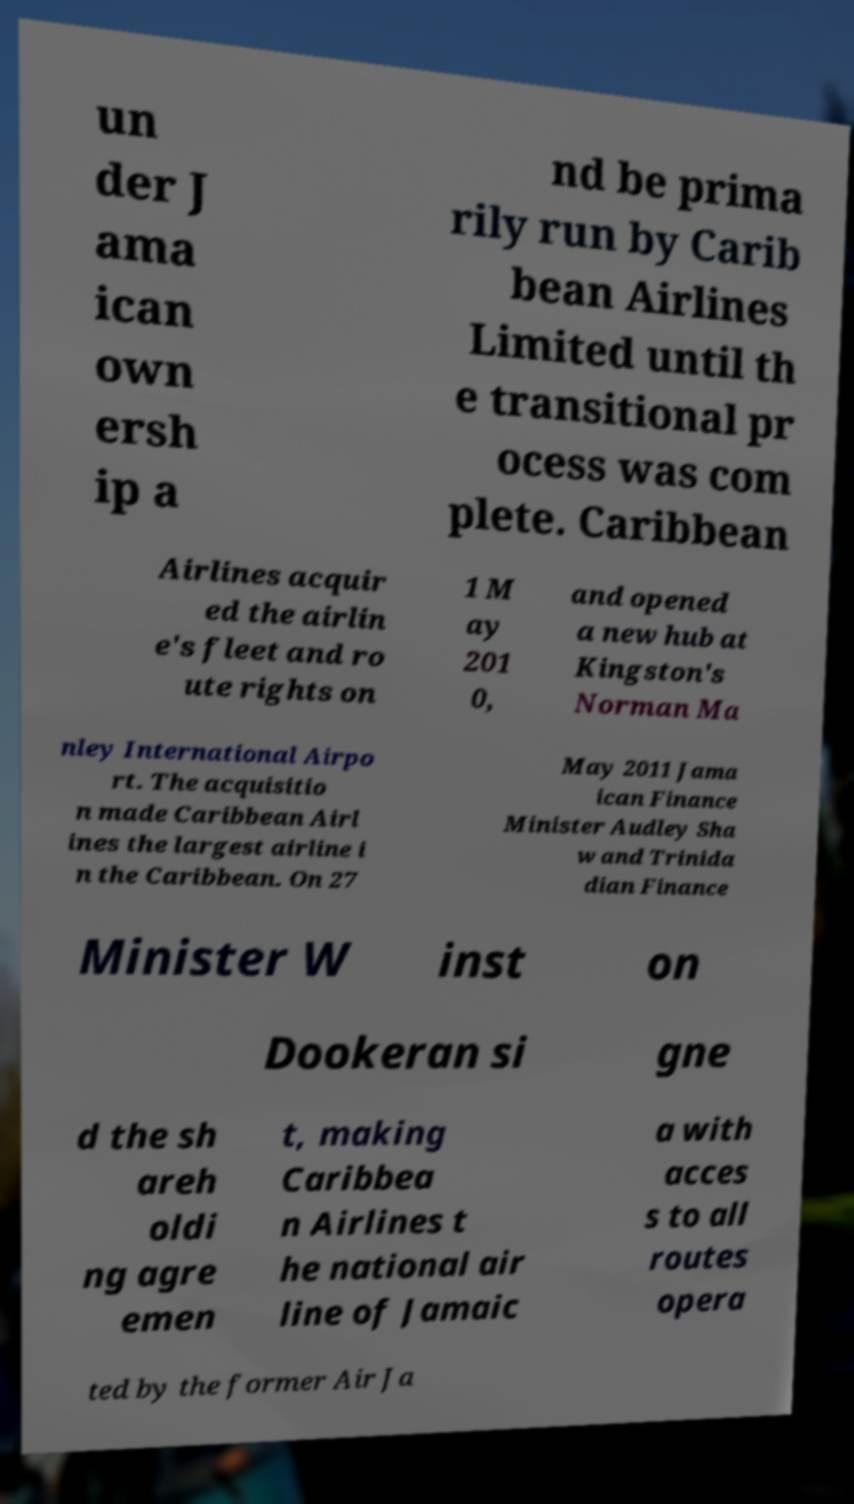I need the written content from this picture converted into text. Can you do that? un der J ama ican own ersh ip a nd be prima rily run by Carib bean Airlines Limited until th e transitional pr ocess was com plete. Caribbean Airlines acquir ed the airlin e's fleet and ro ute rights on 1 M ay 201 0, and opened a new hub at Kingston's Norman Ma nley International Airpo rt. The acquisitio n made Caribbean Airl ines the largest airline i n the Caribbean. On 27 May 2011 Jama ican Finance Minister Audley Sha w and Trinida dian Finance Minister W inst on Dookeran si gne d the sh areh oldi ng agre emen t, making Caribbea n Airlines t he national air line of Jamaic a with acces s to all routes opera ted by the former Air Ja 